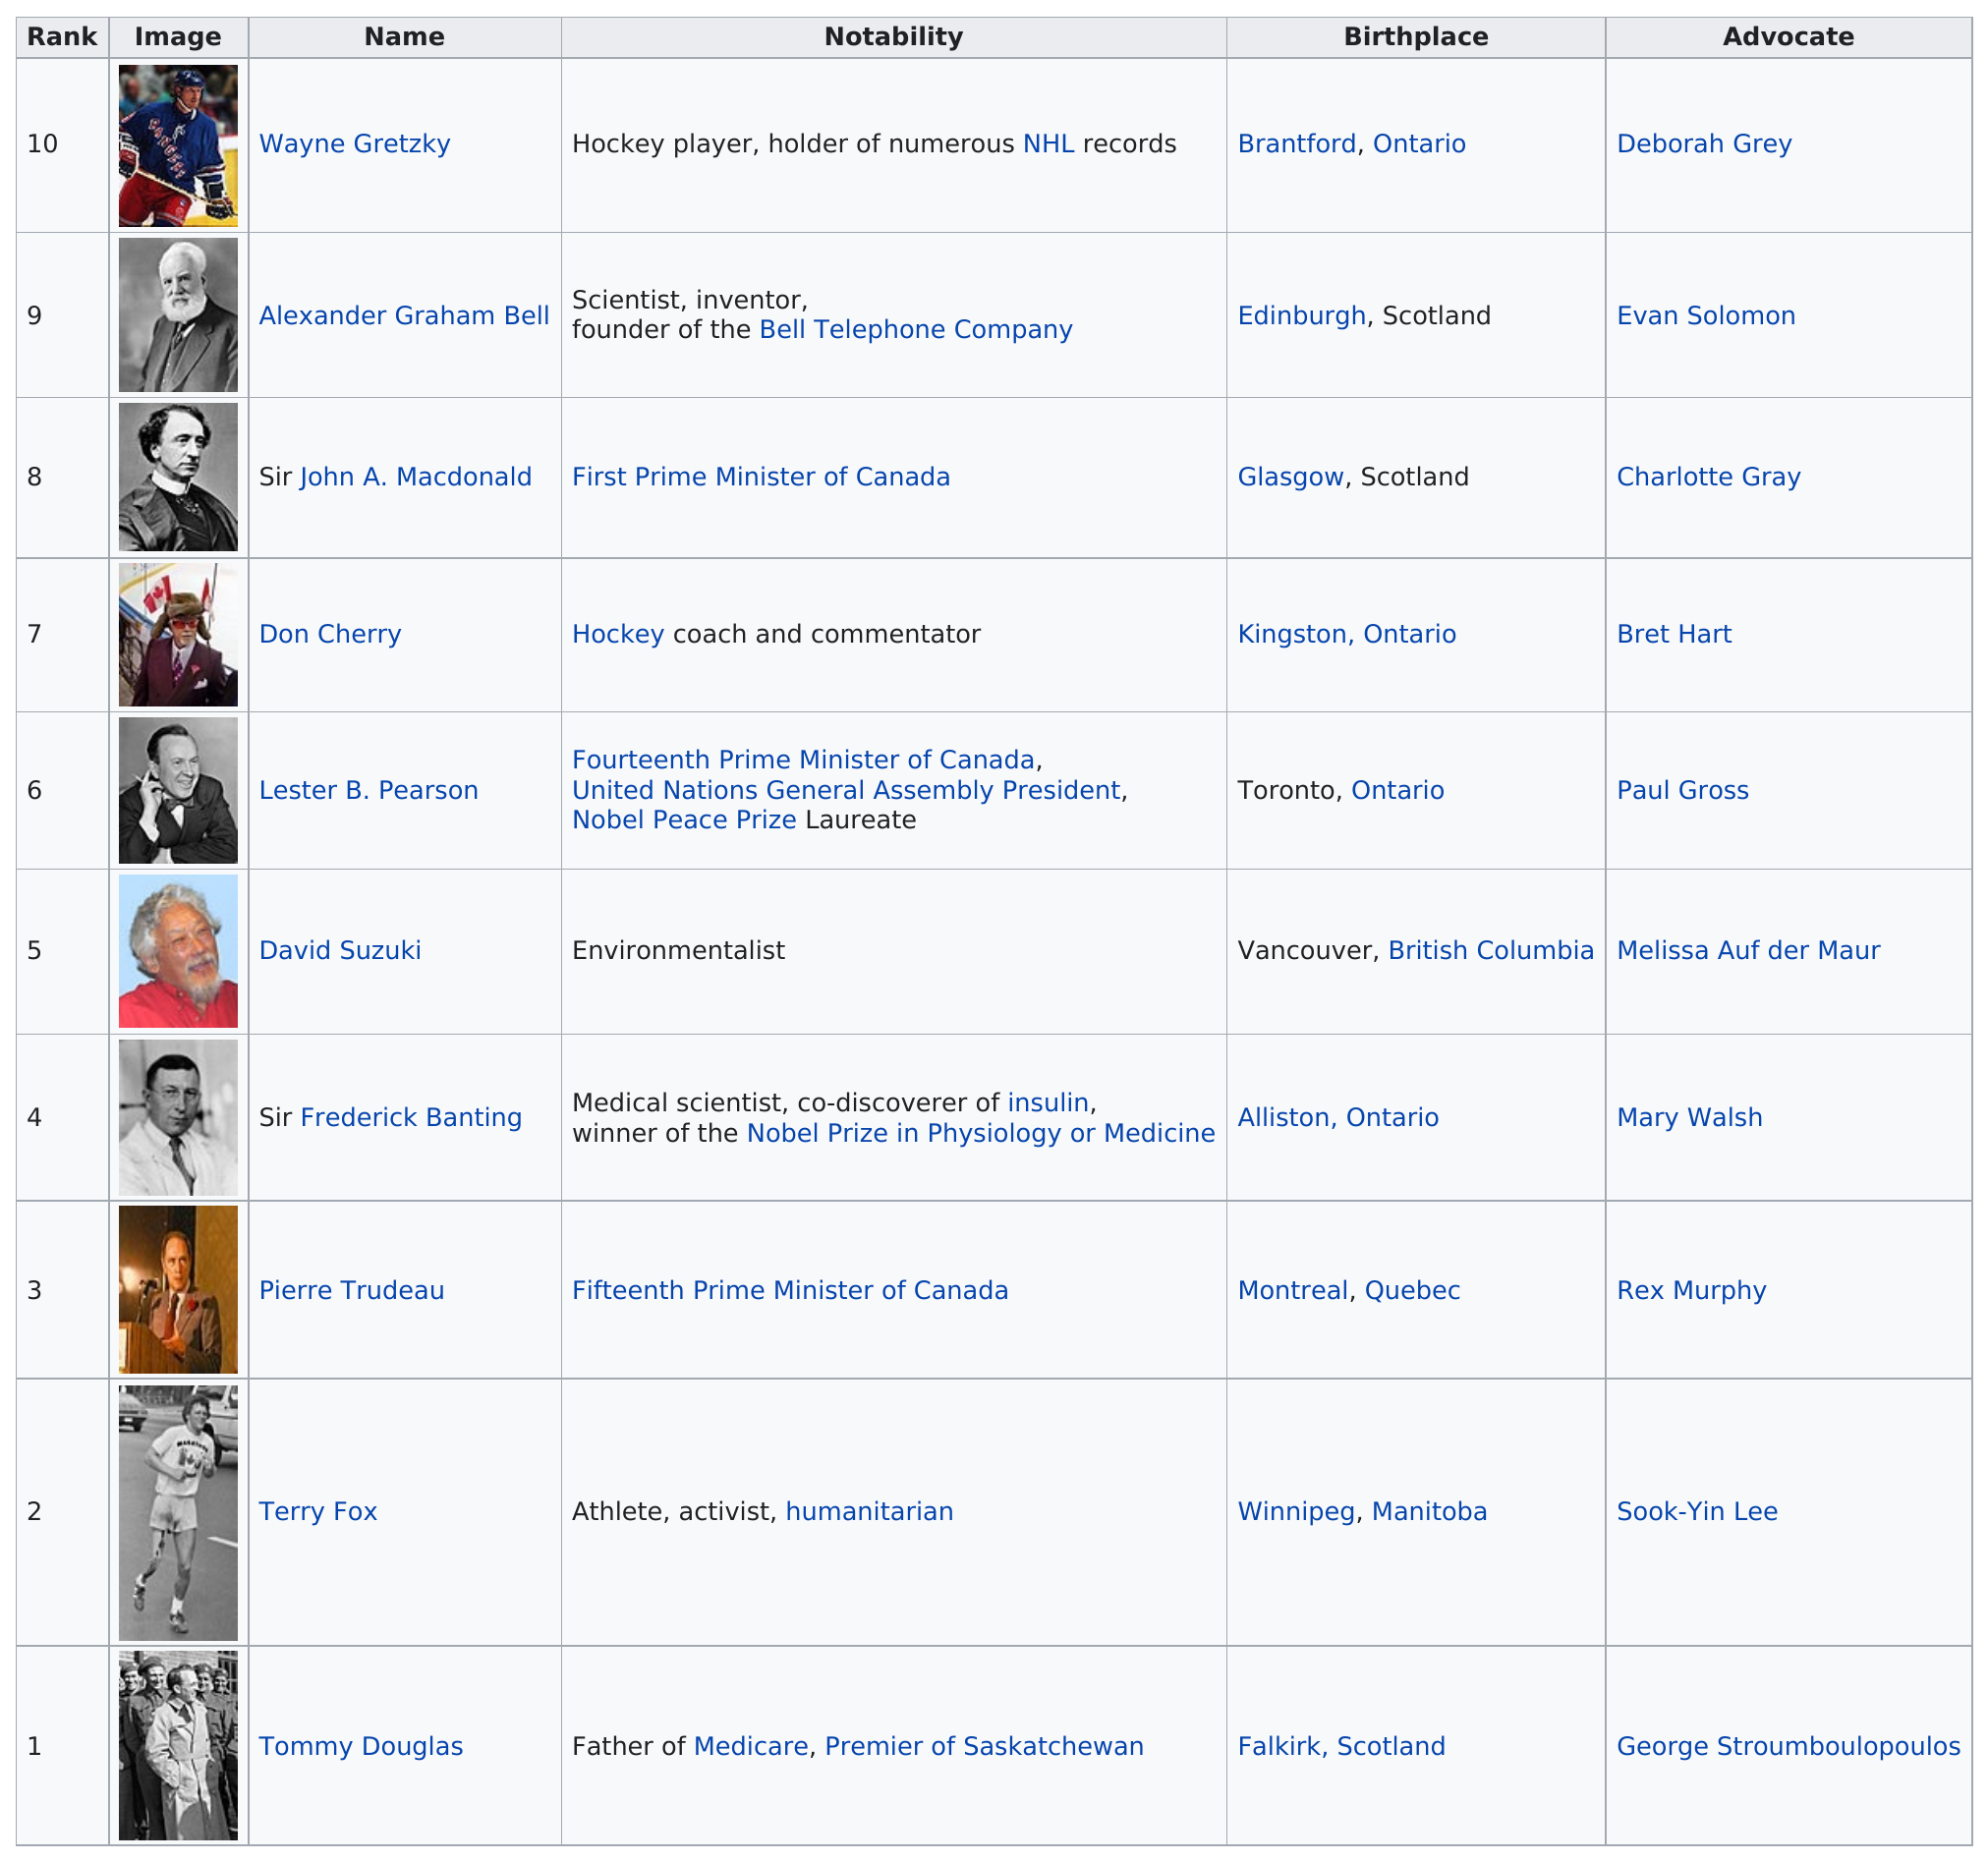List a handful of essential elements in this visual. David Suzuki is the only environmentalist on the list. The name that comes before Wayne Gretzky on the list is Alexander Graham Bell. It is a fact that other than Wayne Gretzky, a Canadian was also involved in hockey. The name of this individual is Don Cherry. The individuals named on the list, including Don Cherry, are Don Cherry, Sir John A. Macdonald, and Lester B. Pearson. Tommy Douglas, a Canadian, was ranked first and considered the greatest among all Canadians. 